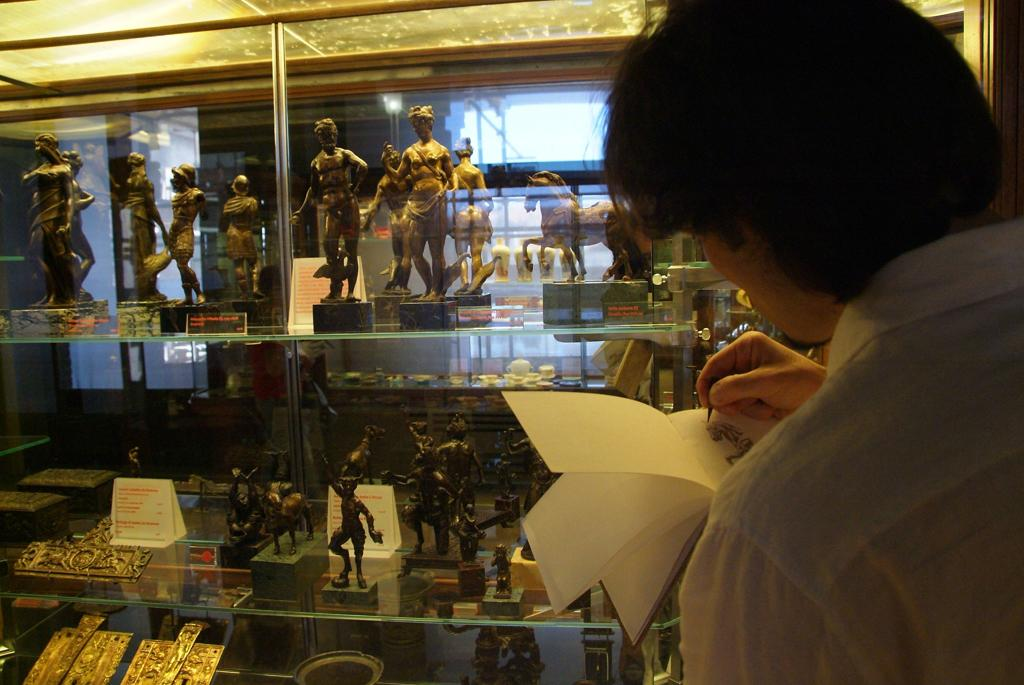What is the person in the image doing? The person in the image is drawing. What is the person drawing on? The person is drawing on a book. What other objects can be seen in the image? There are statues in the image. Where are the statues located? The statues are inside a cupboard. What type of health supplement is the person taking while drawing in the image? There is no indication in the image that the person is taking any health supplements while drawing. 